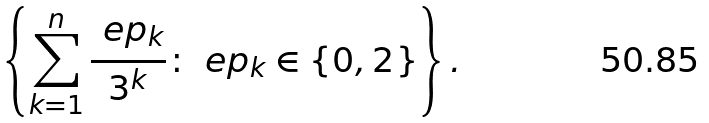<formula> <loc_0><loc_0><loc_500><loc_500>\left \{ \sum _ { k = 1 } ^ { n } \frac { \ e p _ { k } } { 3 ^ { k } } \colon \ e p _ { k } \in \{ 0 , 2 \} \right \} .</formula> 